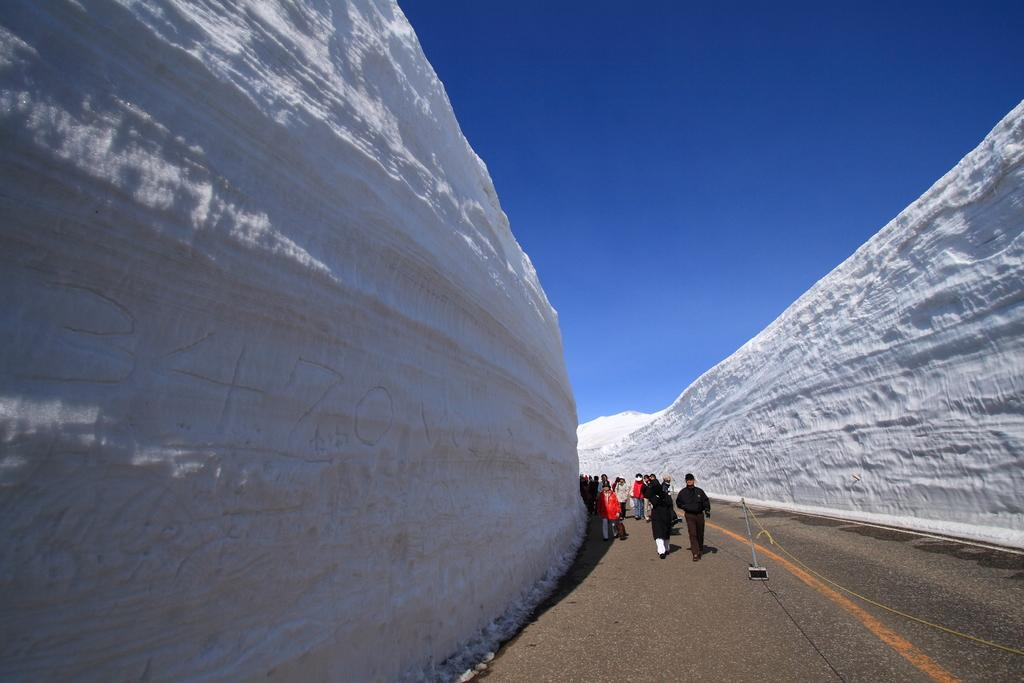What is happening in the image involving a group of people? In the image, some people are walking on the road. Can you describe any objects or structures in the middle of the road? Yes, there is a metal rod in the middle of the road. What type of appliance can be seen in the image? There is no appliance present in the image. Can you tell me how many credits are being exchanged in the image? There is no exchange of credits depicted in the image. 